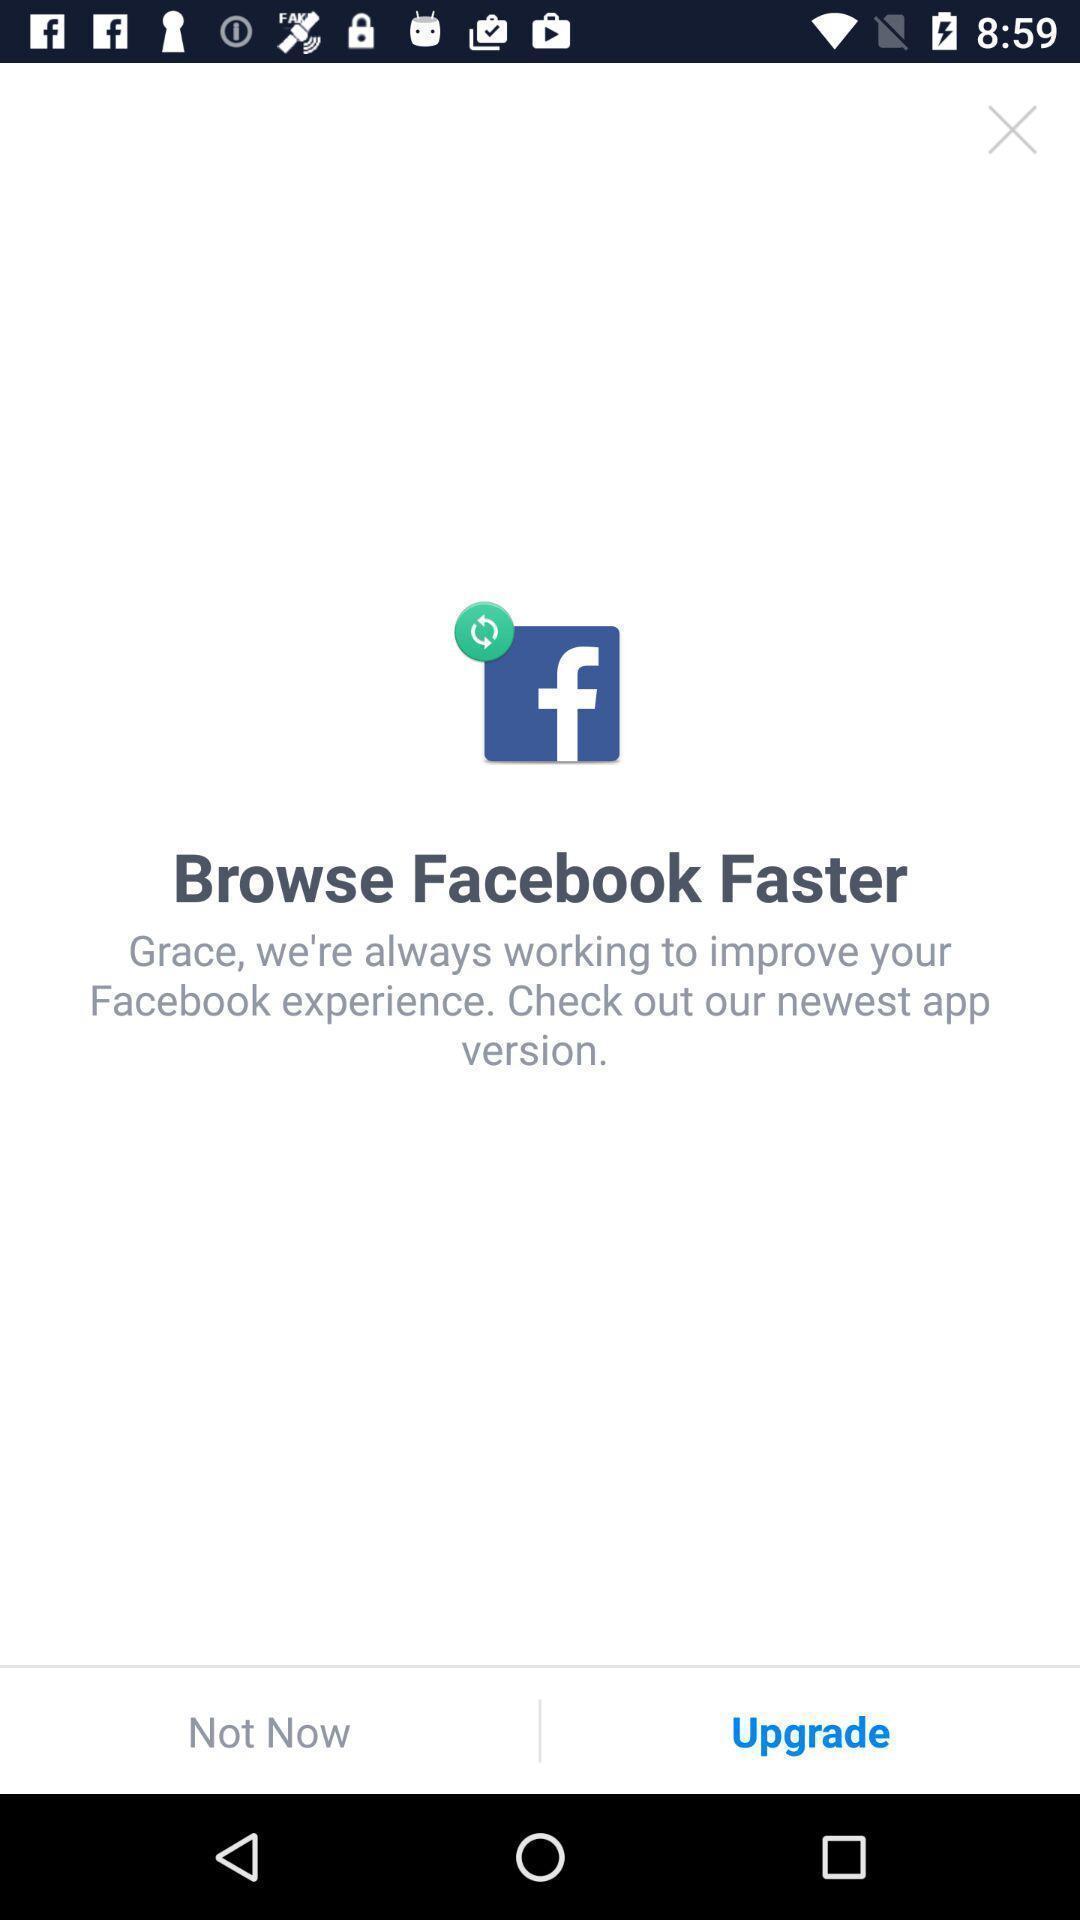Explain what's happening in this screen capture. Upgrade page of social app. 